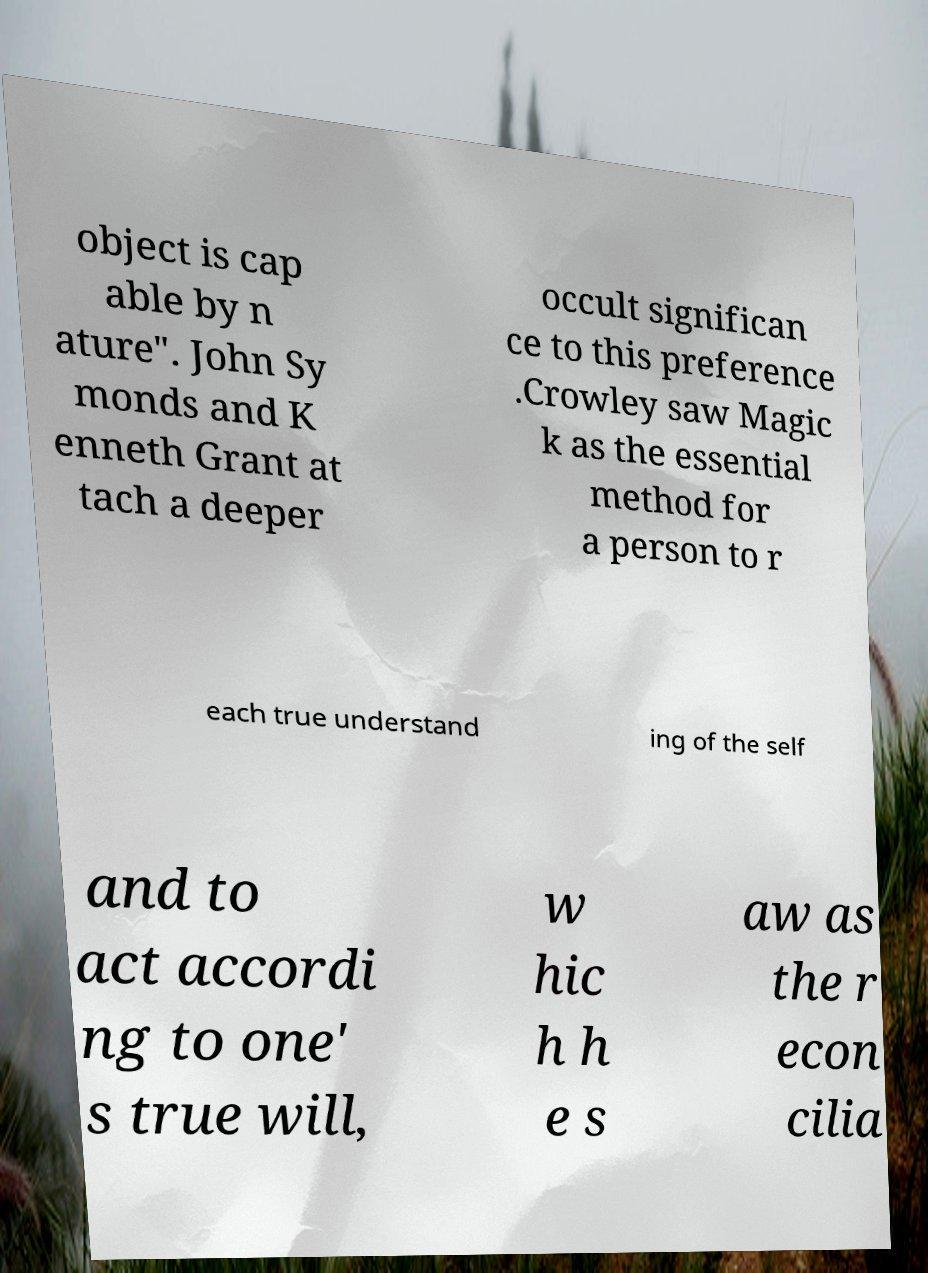Could you assist in decoding the text presented in this image and type it out clearly? object is cap able by n ature". John Sy monds and K enneth Grant at tach a deeper occult significan ce to this preference .Crowley saw Magic k as the essential method for a person to r each true understand ing of the self and to act accordi ng to one' s true will, w hic h h e s aw as the r econ cilia 